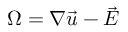Convert formula to latex. <formula><loc_0><loc_0><loc_500><loc_500>\Omega = \nabla \vec { u } - \vec { E }</formula> 